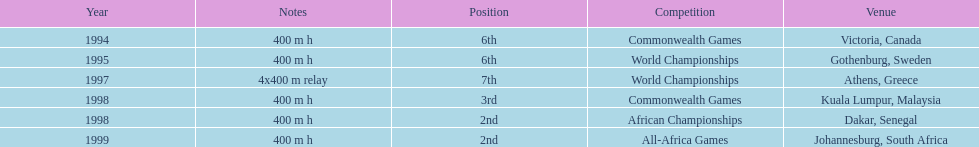Write the full table. {'header': ['Year', 'Notes', 'Position', 'Competition', 'Venue'], 'rows': [['1994', '400 m h', '6th', 'Commonwealth Games', 'Victoria, Canada'], ['1995', '400 m h', '6th', 'World Championships', 'Gothenburg, Sweden'], ['1997', '4x400 m relay', '7th', 'World Championships', 'Athens, Greece'], ['1998', '400 m h', '3rd', 'Commonwealth Games', 'Kuala Lumpur, Malaysia'], ['1998', '400 m h', '2nd', 'African Championships', 'Dakar, Senegal'], ['1999', '400 m h', '2nd', 'All-Africa Games', 'Johannesburg, South Africa']]} In what years did ken harnden do better that 5th place? 1998, 1999. 